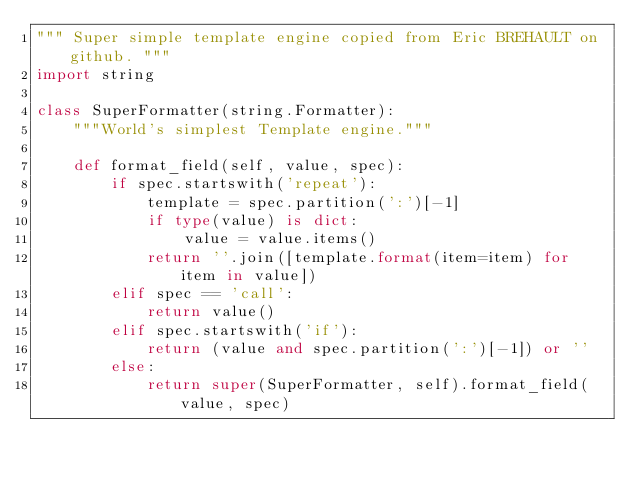Convert code to text. <code><loc_0><loc_0><loc_500><loc_500><_Python_>""" Super simple template engine copied from Eric BREHAULT on github. """
import string

class SuperFormatter(string.Formatter):
    """World's simplest Template engine."""

    def format_field(self, value, spec):
        if spec.startswith('repeat'):
            template = spec.partition(':')[-1]
            if type(value) is dict:
                value = value.items()
            return ''.join([template.format(item=item) for item in value])
        elif spec == 'call':
            return value()
        elif spec.startswith('if'):
            return (value and spec.partition(':')[-1]) or ''
        else:
            return super(SuperFormatter, self).format_field(value, spec)
</code> 